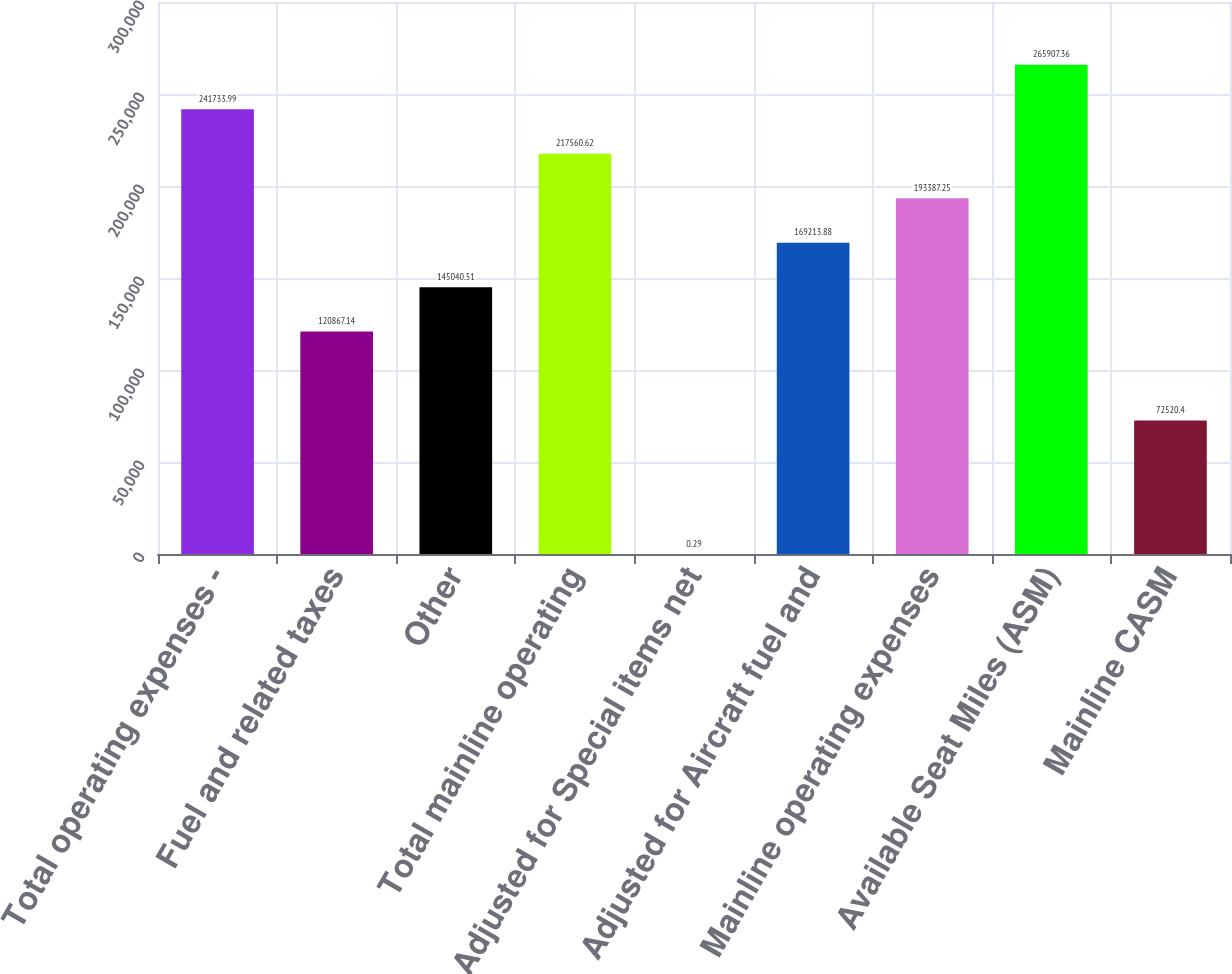<chart> <loc_0><loc_0><loc_500><loc_500><bar_chart><fcel>Total operating expenses -<fcel>Fuel and related taxes<fcel>Other<fcel>Total mainline operating<fcel>Adjusted for Special items net<fcel>Adjusted for Aircraft fuel and<fcel>Mainline operating expenses<fcel>Available Seat Miles (ASM)<fcel>Mainline CASM<nl><fcel>241734<fcel>120867<fcel>145041<fcel>217561<fcel>0.29<fcel>169214<fcel>193387<fcel>265907<fcel>72520.4<nl></chart> 